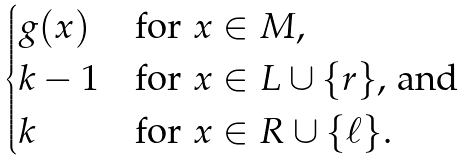Convert formula to latex. <formula><loc_0><loc_0><loc_500><loc_500>\begin{cases} g ( x ) & \text {for $x\in M$,} \\ k - 1 & \text {for $x\in L\cup\{r\}$, and} \\ k & \text {for $x\in R\cup\{\ell\}$.} \end{cases}</formula> 